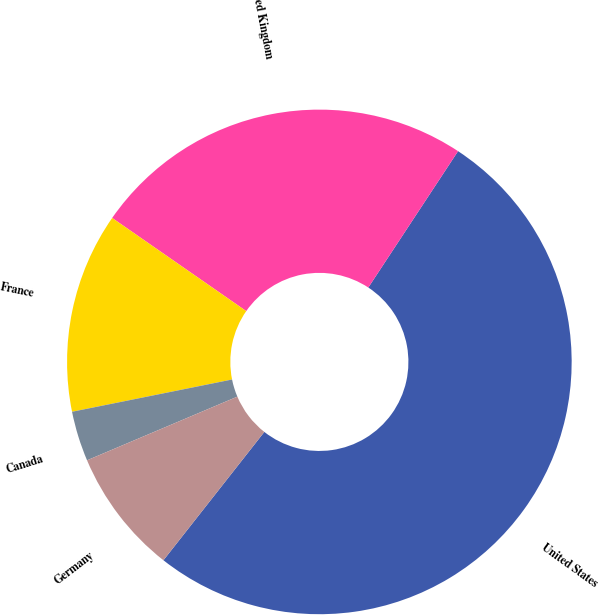<chart> <loc_0><loc_0><loc_500><loc_500><pie_chart><fcel>United States<fcel>United Kingdom<fcel>France<fcel>Canada<fcel>Germany<nl><fcel>51.34%<fcel>24.6%<fcel>12.83%<fcel>3.21%<fcel>8.02%<nl></chart> 